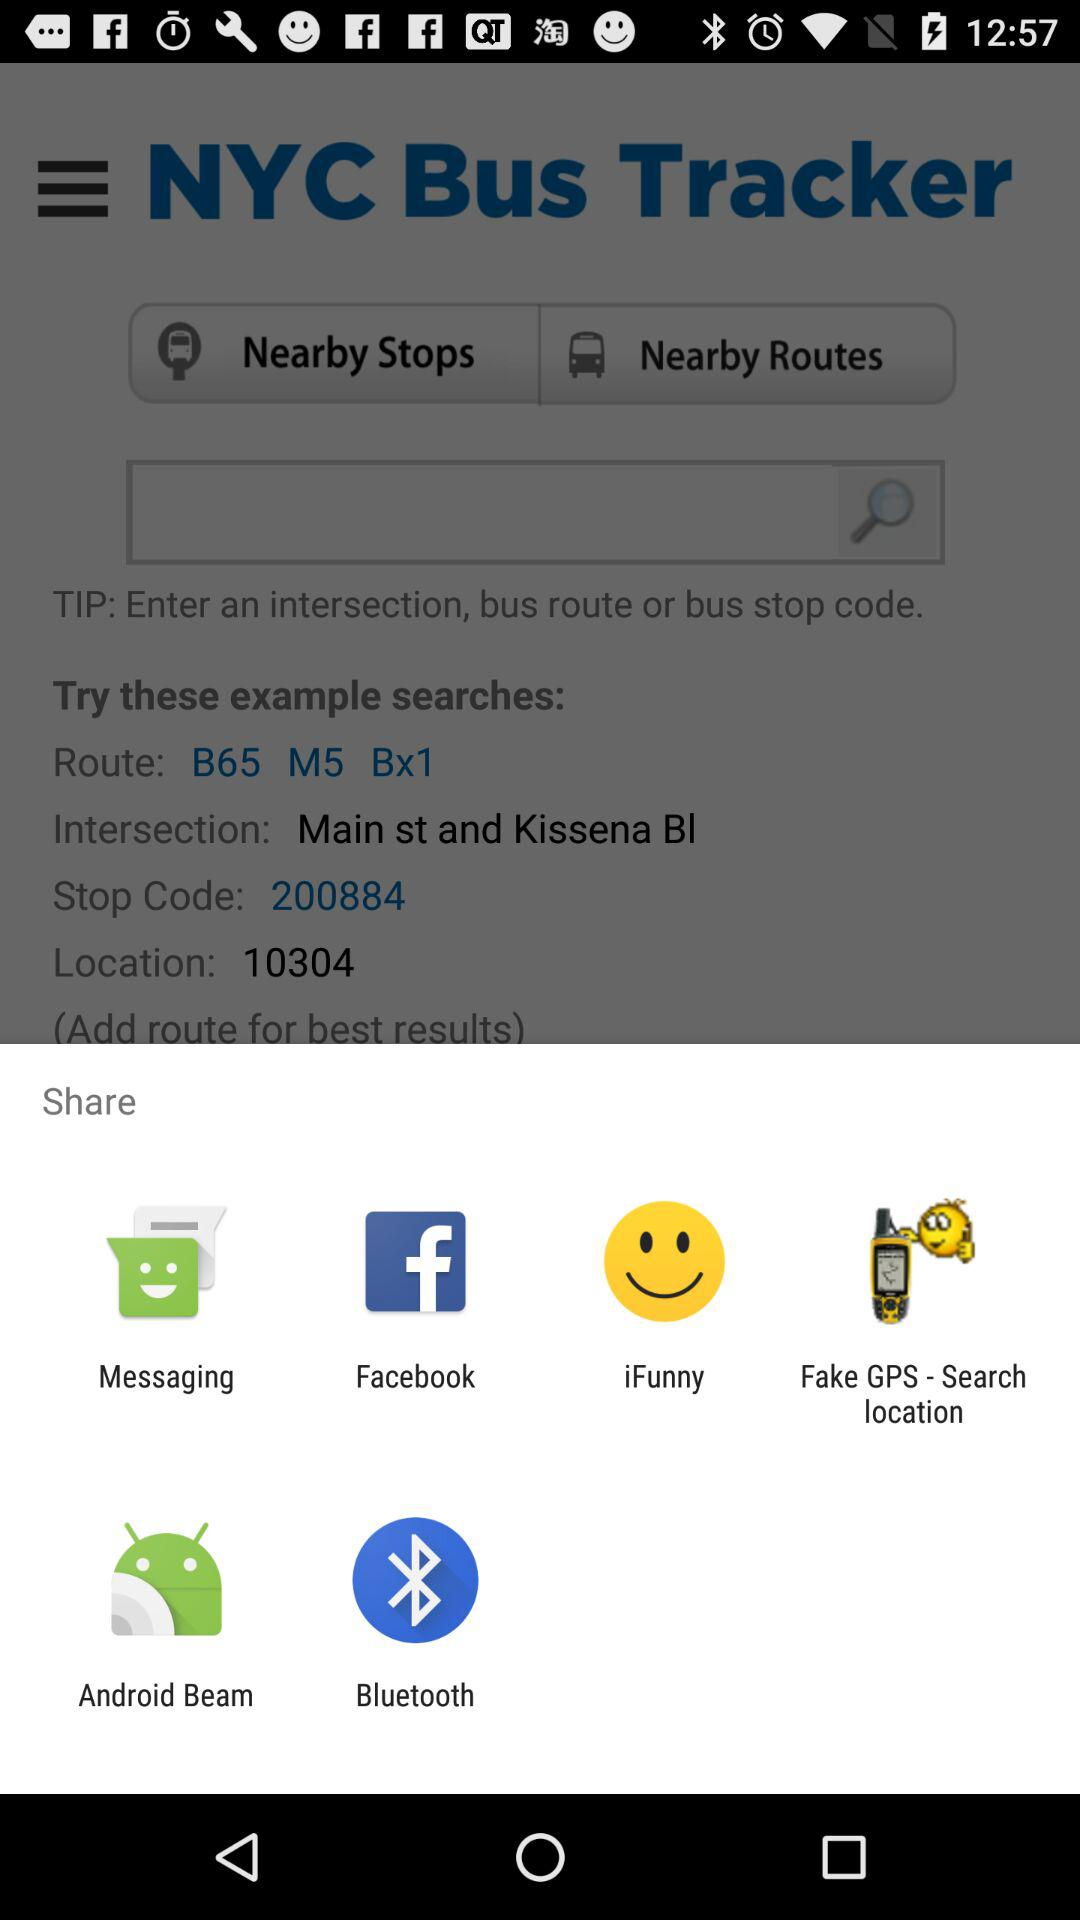What is the intersection place? The intersection place is Main st and Kissena Bl. 